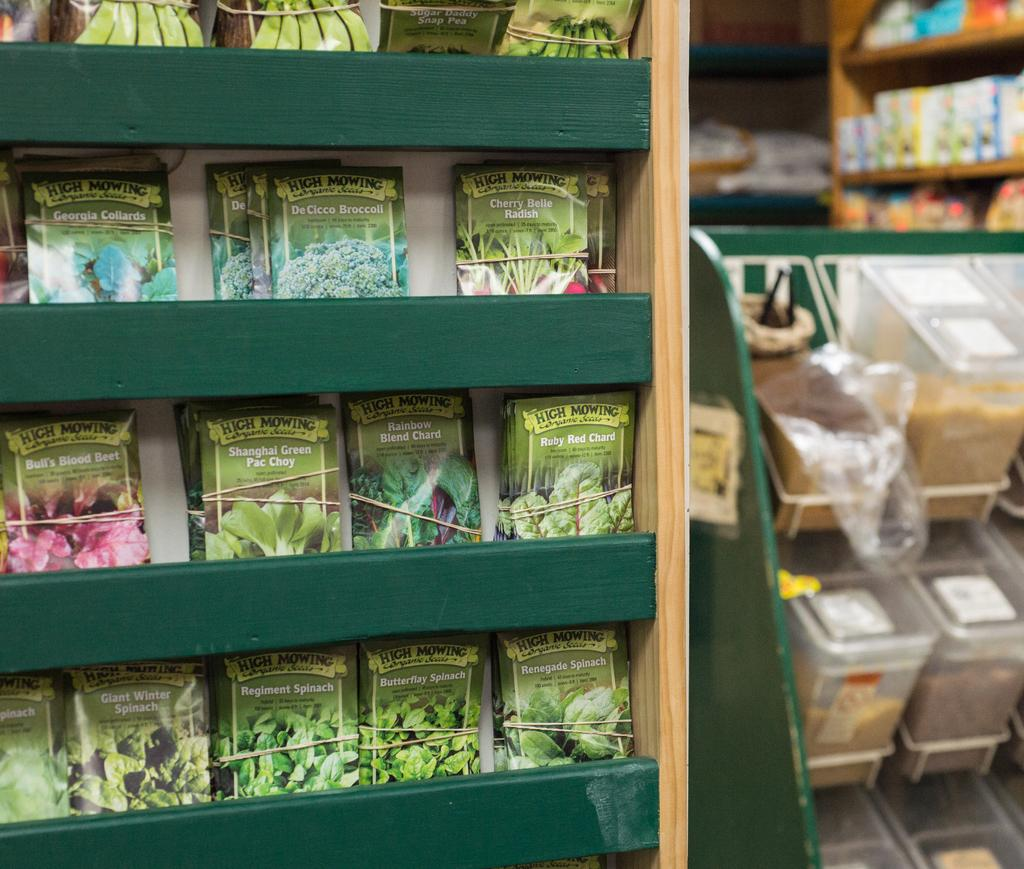<image>
Share a concise interpretation of the image provided. Four rows of plant seeds that include Spinach, Pac Choy, Beets, Radishes, Collards, and Broccoli. 